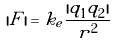Convert formula to latex. <formula><loc_0><loc_0><loc_500><loc_500>| F | = k _ { e } \frac { | q _ { 1 } q _ { 2 } | } { r ^ { 2 } }</formula> 